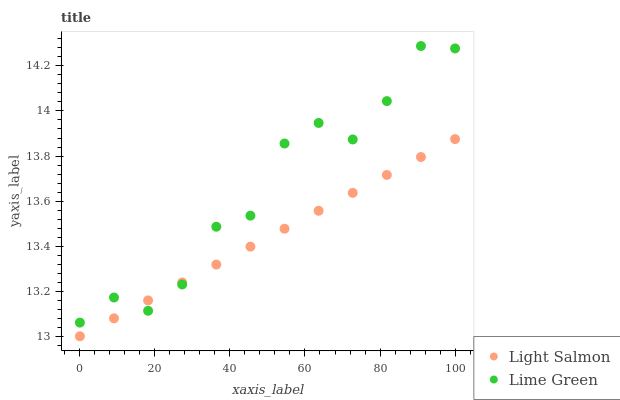Does Light Salmon have the minimum area under the curve?
Answer yes or no. Yes. Does Lime Green have the maximum area under the curve?
Answer yes or no. Yes. Does Lime Green have the minimum area under the curve?
Answer yes or no. No. Is Light Salmon the smoothest?
Answer yes or no. Yes. Is Lime Green the roughest?
Answer yes or no. Yes. Is Lime Green the smoothest?
Answer yes or no. No. Does Light Salmon have the lowest value?
Answer yes or no. Yes. Does Lime Green have the lowest value?
Answer yes or no. No. Does Lime Green have the highest value?
Answer yes or no. Yes. Does Lime Green intersect Light Salmon?
Answer yes or no. Yes. Is Lime Green less than Light Salmon?
Answer yes or no. No. Is Lime Green greater than Light Salmon?
Answer yes or no. No. 